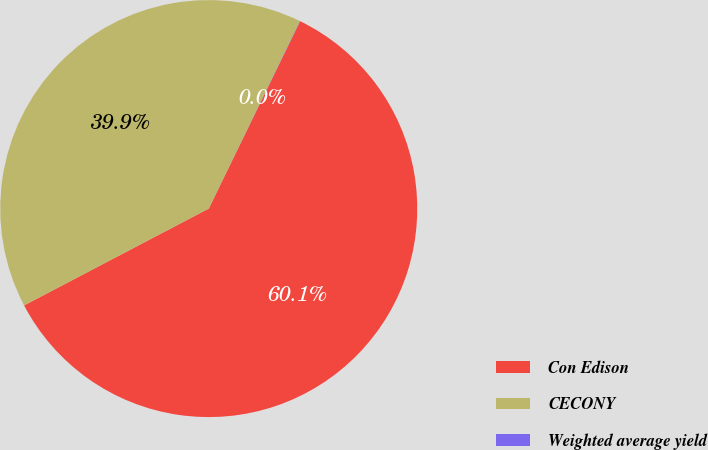Convert chart. <chart><loc_0><loc_0><loc_500><loc_500><pie_chart><fcel>Con Edison<fcel>CECONY<fcel>Weighted average yield<nl><fcel>60.09%<fcel>39.89%<fcel>0.02%<nl></chart> 